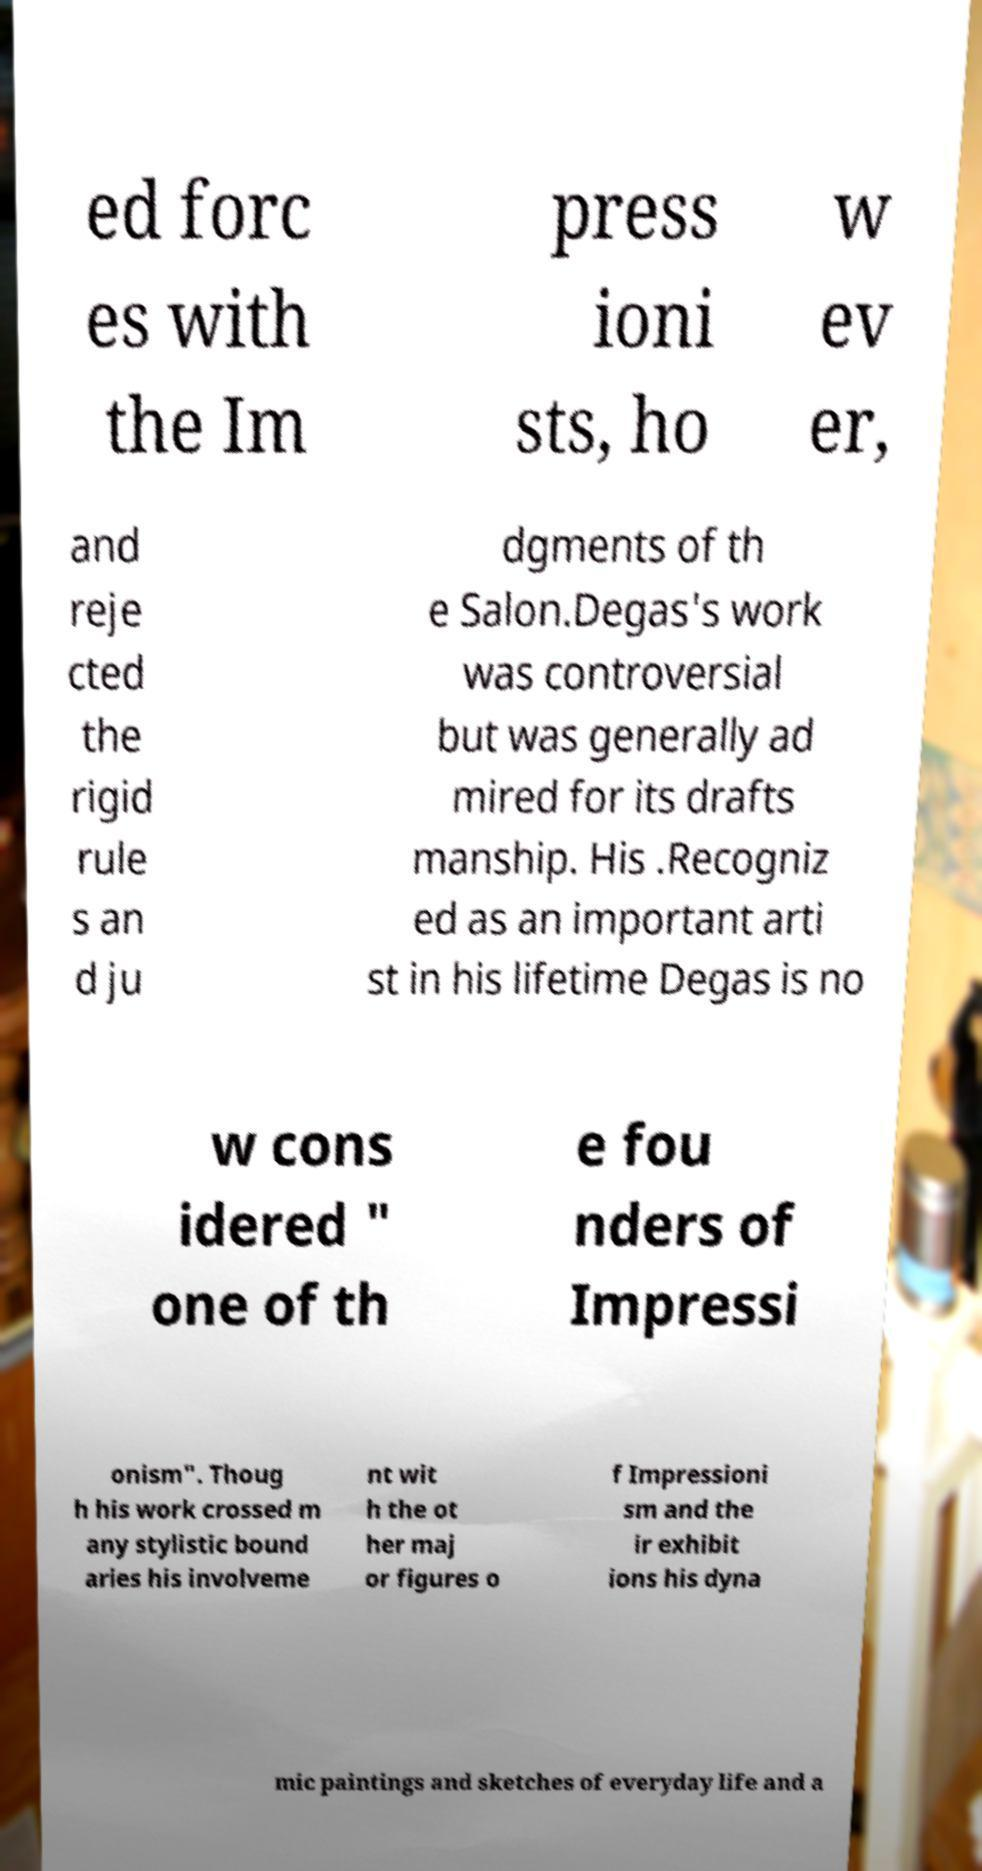There's text embedded in this image that I need extracted. Can you transcribe it verbatim? ed forc es with the Im press ioni sts, ho w ev er, and reje cted the rigid rule s an d ju dgments of th e Salon.Degas's work was controversial but was generally ad mired for its drafts manship. His .Recogniz ed as an important arti st in his lifetime Degas is no w cons idered " one of th e fou nders of Impressi onism". Thoug h his work crossed m any stylistic bound aries his involveme nt wit h the ot her maj or figures o f Impressioni sm and the ir exhibit ions his dyna mic paintings and sketches of everyday life and a 